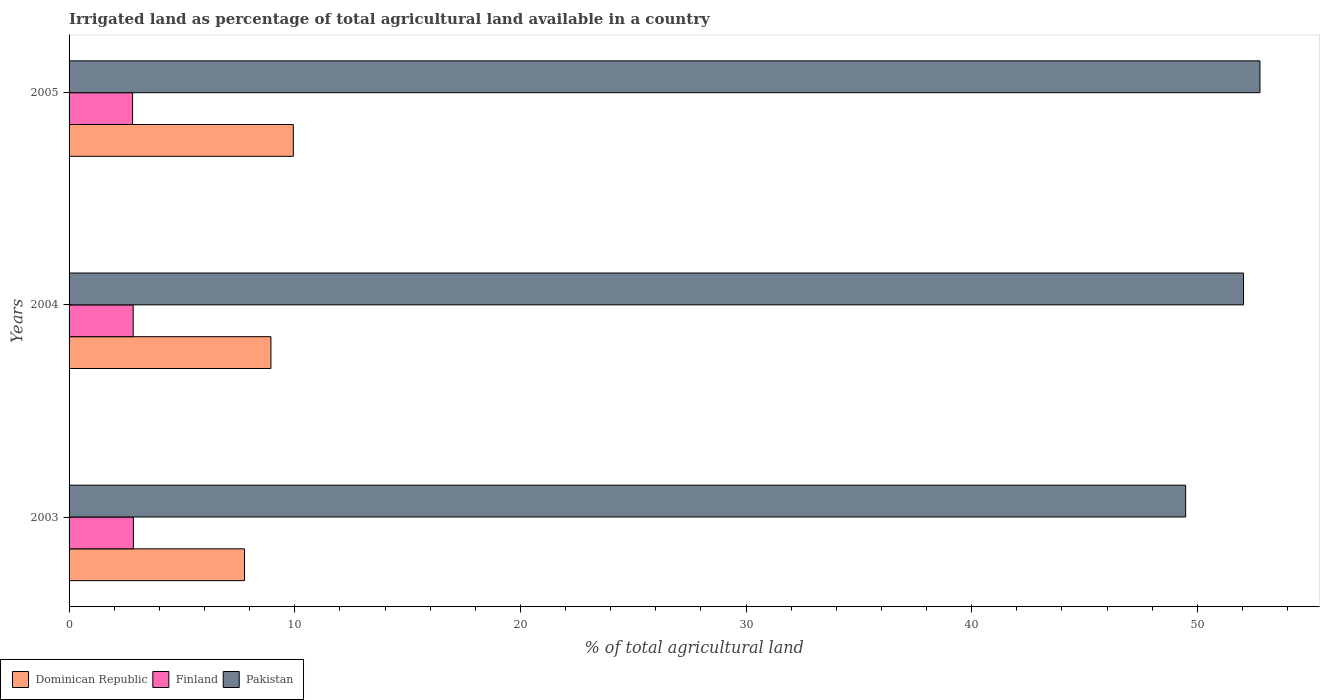How many different coloured bars are there?
Keep it short and to the point. 3. How many groups of bars are there?
Provide a succinct answer. 3. Are the number of bars per tick equal to the number of legend labels?
Offer a very short reply. Yes. Are the number of bars on each tick of the Y-axis equal?
Keep it short and to the point. Yes. How many bars are there on the 1st tick from the bottom?
Ensure brevity in your answer.  3. What is the percentage of irrigated land in Dominican Republic in 2003?
Keep it short and to the point. 7.77. Across all years, what is the maximum percentage of irrigated land in Dominican Republic?
Make the answer very short. 9.94. Across all years, what is the minimum percentage of irrigated land in Dominican Republic?
Give a very brief answer. 7.77. In which year was the percentage of irrigated land in Pakistan minimum?
Ensure brevity in your answer.  2003. What is the total percentage of irrigated land in Dominican Republic in the graph?
Offer a very short reply. 26.66. What is the difference between the percentage of irrigated land in Dominican Republic in 2003 and that in 2004?
Your answer should be very brief. -1.17. What is the difference between the percentage of irrigated land in Finland in 2004 and the percentage of irrigated land in Pakistan in 2005?
Provide a short and direct response. -49.93. What is the average percentage of irrigated land in Pakistan per year?
Make the answer very short. 51.43. In the year 2005, what is the difference between the percentage of irrigated land in Dominican Republic and percentage of irrigated land in Pakistan?
Your response must be concise. -42.84. In how many years, is the percentage of irrigated land in Finland greater than 46 %?
Offer a terse response. 0. What is the ratio of the percentage of irrigated land in Finland in 2004 to that in 2005?
Provide a succinct answer. 1.01. Is the difference between the percentage of irrigated land in Dominican Republic in 2003 and 2004 greater than the difference between the percentage of irrigated land in Pakistan in 2003 and 2004?
Keep it short and to the point. Yes. What is the difference between the highest and the second highest percentage of irrigated land in Finland?
Give a very brief answer. 0.01. What is the difference between the highest and the lowest percentage of irrigated land in Finland?
Your answer should be compact. 0.03. Is the sum of the percentage of irrigated land in Pakistan in 2004 and 2005 greater than the maximum percentage of irrigated land in Finland across all years?
Your answer should be compact. Yes. What does the 1st bar from the bottom in 2004 represents?
Keep it short and to the point. Dominican Republic. How many bars are there?
Give a very brief answer. 9. Are all the bars in the graph horizontal?
Your answer should be compact. Yes. How many years are there in the graph?
Keep it short and to the point. 3. What is the difference between two consecutive major ticks on the X-axis?
Ensure brevity in your answer.  10. Are the values on the major ticks of X-axis written in scientific E-notation?
Your answer should be compact. No. Does the graph contain any zero values?
Your answer should be compact. No. Does the graph contain grids?
Your response must be concise. No. How many legend labels are there?
Make the answer very short. 3. What is the title of the graph?
Offer a very short reply. Irrigated land as percentage of total agricultural land available in a country. Does "Andorra" appear as one of the legend labels in the graph?
Offer a very short reply. No. What is the label or title of the X-axis?
Your response must be concise. % of total agricultural land. What is the % of total agricultural land in Dominican Republic in 2003?
Offer a very short reply. 7.77. What is the % of total agricultural land of Finland in 2003?
Make the answer very short. 2.85. What is the % of total agricultural land in Pakistan in 2003?
Offer a terse response. 49.48. What is the % of total agricultural land in Dominican Republic in 2004?
Offer a terse response. 8.94. What is the % of total agricultural land in Finland in 2004?
Offer a terse response. 2.84. What is the % of total agricultural land in Pakistan in 2004?
Make the answer very short. 52.05. What is the % of total agricultural land in Dominican Republic in 2005?
Your response must be concise. 9.94. What is the % of total agricultural land of Finland in 2005?
Your answer should be very brief. 2.81. What is the % of total agricultural land of Pakistan in 2005?
Provide a short and direct response. 52.77. Across all years, what is the maximum % of total agricultural land of Dominican Republic?
Offer a terse response. 9.94. Across all years, what is the maximum % of total agricultural land of Finland?
Ensure brevity in your answer.  2.85. Across all years, what is the maximum % of total agricultural land of Pakistan?
Provide a short and direct response. 52.77. Across all years, what is the minimum % of total agricultural land in Dominican Republic?
Give a very brief answer. 7.77. Across all years, what is the minimum % of total agricultural land in Finland?
Ensure brevity in your answer.  2.81. Across all years, what is the minimum % of total agricultural land in Pakistan?
Provide a succinct answer. 49.48. What is the total % of total agricultural land in Dominican Republic in the graph?
Your answer should be compact. 26.66. What is the total % of total agricultural land of Finland in the graph?
Your answer should be very brief. 8.5. What is the total % of total agricultural land of Pakistan in the graph?
Your answer should be compact. 154.3. What is the difference between the % of total agricultural land in Dominican Republic in 2003 and that in 2004?
Ensure brevity in your answer.  -1.17. What is the difference between the % of total agricultural land in Finland in 2003 and that in 2004?
Offer a very short reply. 0.01. What is the difference between the % of total agricultural land of Pakistan in 2003 and that in 2004?
Give a very brief answer. -2.56. What is the difference between the % of total agricultural land of Dominican Republic in 2003 and that in 2005?
Keep it short and to the point. -2.16. What is the difference between the % of total agricultural land of Finland in 2003 and that in 2005?
Offer a terse response. 0.03. What is the difference between the % of total agricultural land in Pakistan in 2003 and that in 2005?
Provide a succinct answer. -3.29. What is the difference between the % of total agricultural land of Dominican Republic in 2004 and that in 2005?
Ensure brevity in your answer.  -0.99. What is the difference between the % of total agricultural land in Finland in 2004 and that in 2005?
Ensure brevity in your answer.  0.03. What is the difference between the % of total agricultural land of Pakistan in 2004 and that in 2005?
Your response must be concise. -0.73. What is the difference between the % of total agricultural land in Dominican Republic in 2003 and the % of total agricultural land in Finland in 2004?
Ensure brevity in your answer.  4.93. What is the difference between the % of total agricultural land of Dominican Republic in 2003 and the % of total agricultural land of Pakistan in 2004?
Your response must be concise. -44.27. What is the difference between the % of total agricultural land in Finland in 2003 and the % of total agricultural land in Pakistan in 2004?
Ensure brevity in your answer.  -49.2. What is the difference between the % of total agricultural land of Dominican Republic in 2003 and the % of total agricultural land of Finland in 2005?
Give a very brief answer. 4.96. What is the difference between the % of total agricultural land in Dominican Republic in 2003 and the % of total agricultural land in Pakistan in 2005?
Your response must be concise. -45. What is the difference between the % of total agricultural land of Finland in 2003 and the % of total agricultural land of Pakistan in 2005?
Give a very brief answer. -49.92. What is the difference between the % of total agricultural land in Dominican Republic in 2004 and the % of total agricultural land in Finland in 2005?
Your answer should be very brief. 6.13. What is the difference between the % of total agricultural land in Dominican Republic in 2004 and the % of total agricultural land in Pakistan in 2005?
Ensure brevity in your answer.  -43.83. What is the difference between the % of total agricultural land of Finland in 2004 and the % of total agricultural land of Pakistan in 2005?
Provide a succinct answer. -49.93. What is the average % of total agricultural land in Dominican Republic per year?
Make the answer very short. 8.89. What is the average % of total agricultural land of Finland per year?
Your answer should be very brief. 2.83. What is the average % of total agricultural land in Pakistan per year?
Make the answer very short. 51.43. In the year 2003, what is the difference between the % of total agricultural land of Dominican Republic and % of total agricultural land of Finland?
Provide a short and direct response. 4.92. In the year 2003, what is the difference between the % of total agricultural land in Dominican Republic and % of total agricultural land in Pakistan?
Provide a short and direct response. -41.71. In the year 2003, what is the difference between the % of total agricultural land in Finland and % of total agricultural land in Pakistan?
Your answer should be compact. -46.63. In the year 2004, what is the difference between the % of total agricultural land in Dominican Republic and % of total agricultural land in Finland?
Your answer should be very brief. 6.1. In the year 2004, what is the difference between the % of total agricultural land of Dominican Republic and % of total agricultural land of Pakistan?
Keep it short and to the point. -43.1. In the year 2004, what is the difference between the % of total agricultural land of Finland and % of total agricultural land of Pakistan?
Give a very brief answer. -49.21. In the year 2005, what is the difference between the % of total agricultural land of Dominican Republic and % of total agricultural land of Finland?
Provide a short and direct response. 7.12. In the year 2005, what is the difference between the % of total agricultural land of Dominican Republic and % of total agricultural land of Pakistan?
Your answer should be compact. -42.84. In the year 2005, what is the difference between the % of total agricultural land in Finland and % of total agricultural land in Pakistan?
Your answer should be very brief. -49.96. What is the ratio of the % of total agricultural land in Dominican Republic in 2003 to that in 2004?
Give a very brief answer. 0.87. What is the ratio of the % of total agricultural land in Finland in 2003 to that in 2004?
Provide a succinct answer. 1. What is the ratio of the % of total agricultural land in Pakistan in 2003 to that in 2004?
Keep it short and to the point. 0.95. What is the ratio of the % of total agricultural land of Dominican Republic in 2003 to that in 2005?
Give a very brief answer. 0.78. What is the ratio of the % of total agricultural land in Finland in 2003 to that in 2005?
Provide a short and direct response. 1.01. What is the ratio of the % of total agricultural land in Pakistan in 2003 to that in 2005?
Provide a succinct answer. 0.94. What is the ratio of the % of total agricultural land of Dominican Republic in 2004 to that in 2005?
Your answer should be compact. 0.9. What is the ratio of the % of total agricultural land in Finland in 2004 to that in 2005?
Your answer should be compact. 1.01. What is the ratio of the % of total agricultural land of Pakistan in 2004 to that in 2005?
Provide a succinct answer. 0.99. What is the difference between the highest and the second highest % of total agricultural land of Dominican Republic?
Offer a terse response. 0.99. What is the difference between the highest and the second highest % of total agricultural land in Finland?
Provide a short and direct response. 0.01. What is the difference between the highest and the second highest % of total agricultural land of Pakistan?
Provide a succinct answer. 0.73. What is the difference between the highest and the lowest % of total agricultural land of Dominican Republic?
Your answer should be very brief. 2.16. What is the difference between the highest and the lowest % of total agricultural land in Finland?
Make the answer very short. 0.03. What is the difference between the highest and the lowest % of total agricultural land in Pakistan?
Provide a short and direct response. 3.29. 